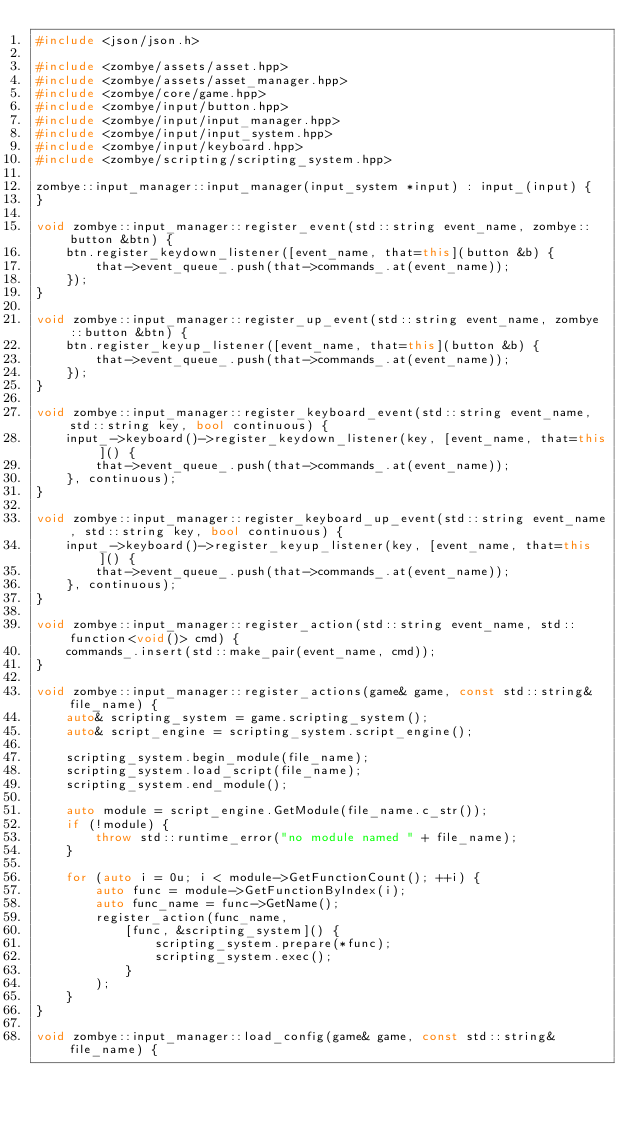<code> <loc_0><loc_0><loc_500><loc_500><_C++_>#include <json/json.h>

#include <zombye/assets/asset.hpp>
#include <zombye/assets/asset_manager.hpp>
#include <zombye/core/game.hpp>
#include <zombye/input/button.hpp>
#include <zombye/input/input_manager.hpp>
#include <zombye/input/input_system.hpp>
#include <zombye/input/keyboard.hpp>
#include <zombye/scripting/scripting_system.hpp>

zombye::input_manager::input_manager(input_system *input) : input_(input) {
}

void zombye::input_manager::register_event(std::string event_name, zombye::button &btn) {
    btn.register_keydown_listener([event_name, that=this](button &b) {
        that->event_queue_.push(that->commands_.at(event_name));
    });
}

void zombye::input_manager::register_up_event(std::string event_name, zombye::button &btn) {
    btn.register_keyup_listener([event_name, that=this](button &b) {
        that->event_queue_.push(that->commands_.at(event_name));
    });
}

void zombye::input_manager::register_keyboard_event(std::string event_name, std::string key, bool continuous) {
    input_->keyboard()->register_keydown_listener(key, [event_name, that=this]() {
        that->event_queue_.push(that->commands_.at(event_name));
    }, continuous);
}

void zombye::input_manager::register_keyboard_up_event(std::string event_name, std::string key, bool continuous) {
    input_->keyboard()->register_keyup_listener(key, [event_name, that=this]() {
        that->event_queue_.push(that->commands_.at(event_name));
    }, continuous);
}

void zombye::input_manager::register_action(std::string event_name, std::function<void()> cmd) {
    commands_.insert(std::make_pair(event_name, cmd));
}

void zombye::input_manager::register_actions(game& game, const std::string& file_name) {
    auto& scripting_system = game.scripting_system();
    auto& script_engine = scripting_system.script_engine();

    scripting_system.begin_module(file_name);
    scripting_system.load_script(file_name);
    scripting_system.end_module();

    auto module = script_engine.GetModule(file_name.c_str());
    if (!module) {
        throw std::runtime_error("no module named " + file_name);
    }

    for (auto i = 0u; i < module->GetFunctionCount(); ++i) {
        auto func = module->GetFunctionByIndex(i);
        auto func_name = func->GetName();
        register_action(func_name,
            [func, &scripting_system]() {
                scripting_system.prepare(*func);
                scripting_system.exec();
            }
        );
    }
}

void zombye::input_manager::load_config(game& game, const std::string& file_name) {</code> 